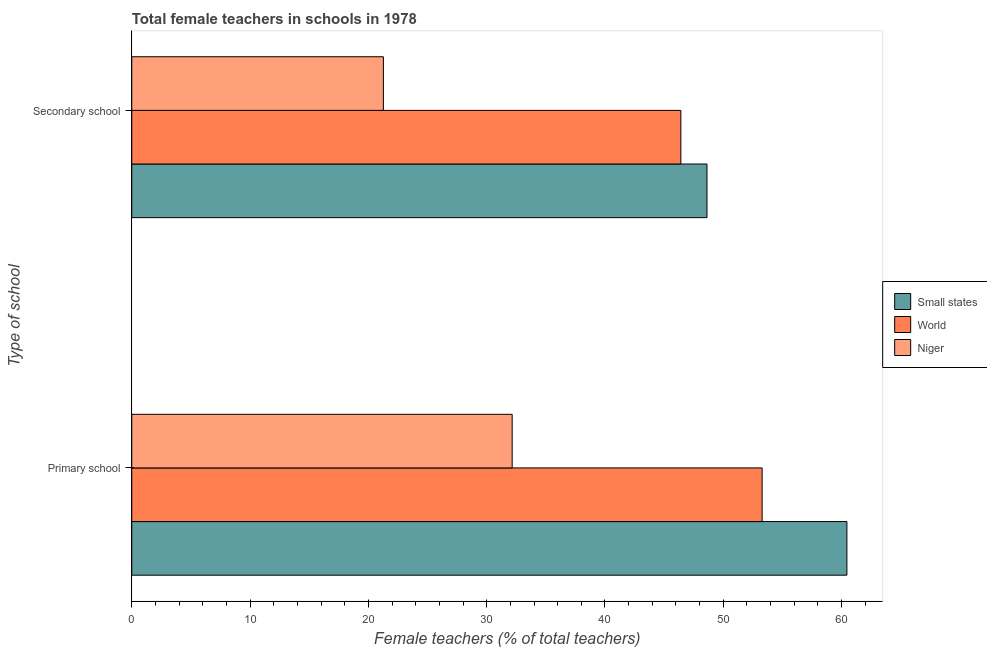Are the number of bars on each tick of the Y-axis equal?
Offer a terse response. Yes. How many bars are there on the 1st tick from the top?
Provide a succinct answer. 3. What is the label of the 1st group of bars from the top?
Make the answer very short. Secondary school. What is the percentage of female teachers in secondary schools in Niger?
Offer a terse response. 21.27. Across all countries, what is the maximum percentage of female teachers in secondary schools?
Make the answer very short. 48.62. Across all countries, what is the minimum percentage of female teachers in primary schools?
Your response must be concise. 32.15. In which country was the percentage of female teachers in primary schools maximum?
Provide a short and direct response. Small states. In which country was the percentage of female teachers in secondary schools minimum?
Your answer should be very brief. Niger. What is the total percentage of female teachers in primary schools in the graph?
Your answer should be very brief. 145.88. What is the difference between the percentage of female teachers in primary schools in Small states and that in World?
Offer a terse response. 7.17. What is the difference between the percentage of female teachers in primary schools in World and the percentage of female teachers in secondary schools in Small states?
Provide a succinct answer. 4.66. What is the average percentage of female teachers in secondary schools per country?
Ensure brevity in your answer.  38.77. What is the difference between the percentage of female teachers in secondary schools and percentage of female teachers in primary schools in Small states?
Your answer should be compact. -11.83. In how many countries, is the percentage of female teachers in secondary schools greater than 6 %?
Ensure brevity in your answer.  3. What is the ratio of the percentage of female teachers in primary schools in Niger to that in World?
Ensure brevity in your answer.  0.6. In how many countries, is the percentage of female teachers in primary schools greater than the average percentage of female teachers in primary schools taken over all countries?
Provide a succinct answer. 2. What does the 1st bar from the bottom in Primary school represents?
Ensure brevity in your answer.  Small states. How many bars are there?
Keep it short and to the point. 6. Are all the bars in the graph horizontal?
Your answer should be compact. Yes. What is the title of the graph?
Offer a very short reply. Total female teachers in schools in 1978. Does "Yemen, Rep." appear as one of the legend labels in the graph?
Provide a succinct answer. No. What is the label or title of the X-axis?
Provide a short and direct response. Female teachers (% of total teachers). What is the label or title of the Y-axis?
Give a very brief answer. Type of school. What is the Female teachers (% of total teachers) in Small states in Primary school?
Provide a succinct answer. 60.45. What is the Female teachers (% of total teachers) of World in Primary school?
Keep it short and to the point. 53.28. What is the Female teachers (% of total teachers) of Niger in Primary school?
Offer a very short reply. 32.15. What is the Female teachers (% of total teachers) of Small states in Secondary school?
Ensure brevity in your answer.  48.62. What is the Female teachers (% of total teachers) of World in Secondary school?
Ensure brevity in your answer.  46.41. What is the Female teachers (% of total teachers) of Niger in Secondary school?
Your answer should be very brief. 21.27. Across all Type of school, what is the maximum Female teachers (% of total teachers) in Small states?
Your response must be concise. 60.45. Across all Type of school, what is the maximum Female teachers (% of total teachers) of World?
Keep it short and to the point. 53.28. Across all Type of school, what is the maximum Female teachers (% of total teachers) of Niger?
Provide a short and direct response. 32.15. Across all Type of school, what is the minimum Female teachers (% of total teachers) of Small states?
Offer a very short reply. 48.62. Across all Type of school, what is the minimum Female teachers (% of total teachers) of World?
Provide a short and direct response. 46.41. Across all Type of school, what is the minimum Female teachers (% of total teachers) of Niger?
Ensure brevity in your answer.  21.27. What is the total Female teachers (% of total teachers) in Small states in the graph?
Make the answer very short. 109.07. What is the total Female teachers (% of total teachers) of World in the graph?
Your answer should be very brief. 99.69. What is the total Female teachers (% of total teachers) of Niger in the graph?
Your answer should be very brief. 53.42. What is the difference between the Female teachers (% of total teachers) in Small states in Primary school and that in Secondary school?
Give a very brief answer. 11.83. What is the difference between the Female teachers (% of total teachers) in World in Primary school and that in Secondary school?
Your answer should be compact. 6.87. What is the difference between the Female teachers (% of total teachers) in Niger in Primary school and that in Secondary school?
Keep it short and to the point. 10.89. What is the difference between the Female teachers (% of total teachers) in Small states in Primary school and the Female teachers (% of total teachers) in World in Secondary school?
Ensure brevity in your answer.  14.03. What is the difference between the Female teachers (% of total teachers) of Small states in Primary school and the Female teachers (% of total teachers) of Niger in Secondary school?
Offer a very short reply. 39.18. What is the difference between the Female teachers (% of total teachers) of World in Primary school and the Female teachers (% of total teachers) of Niger in Secondary school?
Ensure brevity in your answer.  32.01. What is the average Female teachers (% of total teachers) of Small states per Type of school?
Offer a very short reply. 54.53. What is the average Female teachers (% of total teachers) of World per Type of school?
Offer a very short reply. 49.85. What is the average Female teachers (% of total teachers) of Niger per Type of school?
Your answer should be compact. 26.71. What is the difference between the Female teachers (% of total teachers) of Small states and Female teachers (% of total teachers) of World in Primary school?
Your answer should be very brief. 7.17. What is the difference between the Female teachers (% of total teachers) of Small states and Female teachers (% of total teachers) of Niger in Primary school?
Keep it short and to the point. 28.29. What is the difference between the Female teachers (% of total teachers) of World and Female teachers (% of total teachers) of Niger in Primary school?
Offer a very short reply. 21.13. What is the difference between the Female teachers (% of total teachers) of Small states and Female teachers (% of total teachers) of World in Secondary school?
Offer a terse response. 2.21. What is the difference between the Female teachers (% of total teachers) of Small states and Female teachers (% of total teachers) of Niger in Secondary school?
Make the answer very short. 27.35. What is the difference between the Female teachers (% of total teachers) of World and Female teachers (% of total teachers) of Niger in Secondary school?
Offer a very short reply. 25.14. What is the ratio of the Female teachers (% of total teachers) in Small states in Primary school to that in Secondary school?
Keep it short and to the point. 1.24. What is the ratio of the Female teachers (% of total teachers) in World in Primary school to that in Secondary school?
Make the answer very short. 1.15. What is the ratio of the Female teachers (% of total teachers) of Niger in Primary school to that in Secondary school?
Offer a terse response. 1.51. What is the difference between the highest and the second highest Female teachers (% of total teachers) in Small states?
Ensure brevity in your answer.  11.83. What is the difference between the highest and the second highest Female teachers (% of total teachers) of World?
Your answer should be very brief. 6.87. What is the difference between the highest and the second highest Female teachers (% of total teachers) of Niger?
Provide a short and direct response. 10.89. What is the difference between the highest and the lowest Female teachers (% of total teachers) of Small states?
Your response must be concise. 11.83. What is the difference between the highest and the lowest Female teachers (% of total teachers) in World?
Your response must be concise. 6.87. What is the difference between the highest and the lowest Female teachers (% of total teachers) of Niger?
Keep it short and to the point. 10.89. 